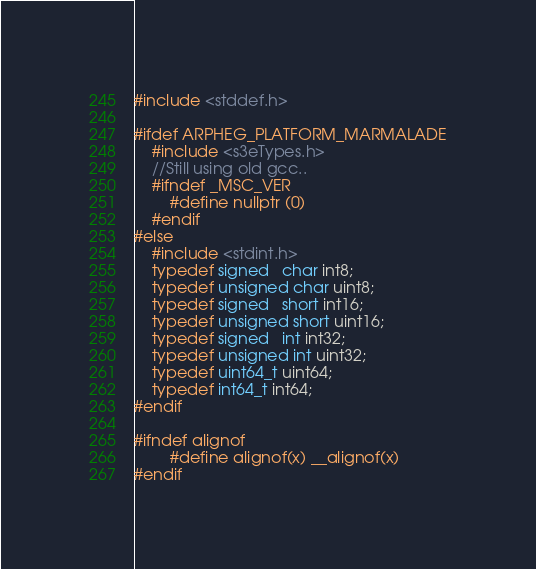<code> <loc_0><loc_0><loc_500><loc_500><_C_>
#include <stddef.h>

#ifdef ARPHEG_PLATFORM_MARMALADE
	#include <s3eTypes.h>
	//Still using old gcc..
	#ifndef _MSC_VER
		#define nullptr (0)
	#endif
#else
	#include <stdint.h>
	typedef signed   char int8;
	typedef unsigned char uint8;
	typedef signed   short int16;
	typedef unsigned short uint16;
	typedef signed   int int32;
	typedef unsigned int uint32;
	typedef uint64_t uint64;
	typedef int64_t int64;
#endif

#ifndef alignof
        #define alignof(x) __alignof(x)
#endif
</code> 